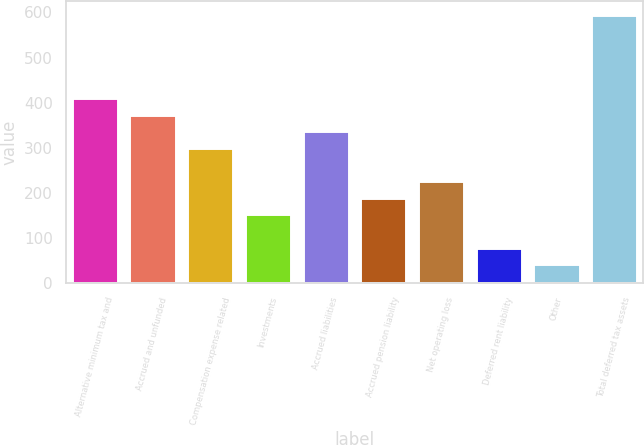Convert chart to OTSL. <chart><loc_0><loc_0><loc_500><loc_500><bar_chart><fcel>Alternative minimum tax and<fcel>Accrued and unfunded<fcel>Compensation expense related<fcel>Investments<fcel>Accrued liabilities<fcel>Accrued pension liability<fcel>Net operating loss<fcel>Deferred rent liability<fcel>Other<fcel>Total deferred tax assets<nl><fcel>410.38<fcel>373.5<fcel>299.74<fcel>152.22<fcel>336.62<fcel>189.1<fcel>225.98<fcel>78.46<fcel>41.58<fcel>594.78<nl></chart> 